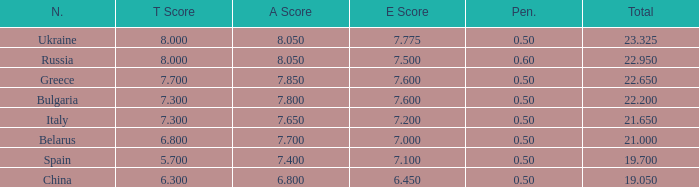What E score has the T score of 8 and a number smaller than 22.95? None. 